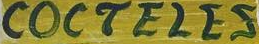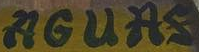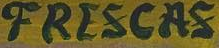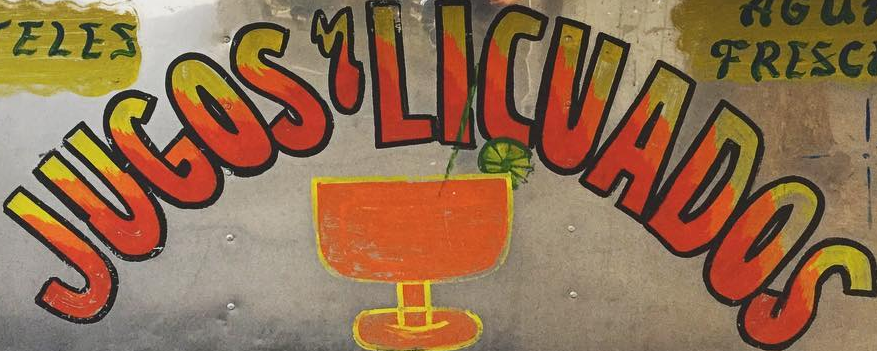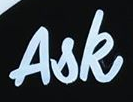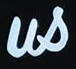Read the text content from these images in order, separated by a semicolon. COCTELES; AGUAS; FRESCAS; JUGOS'LICUADOS; Ask; us 